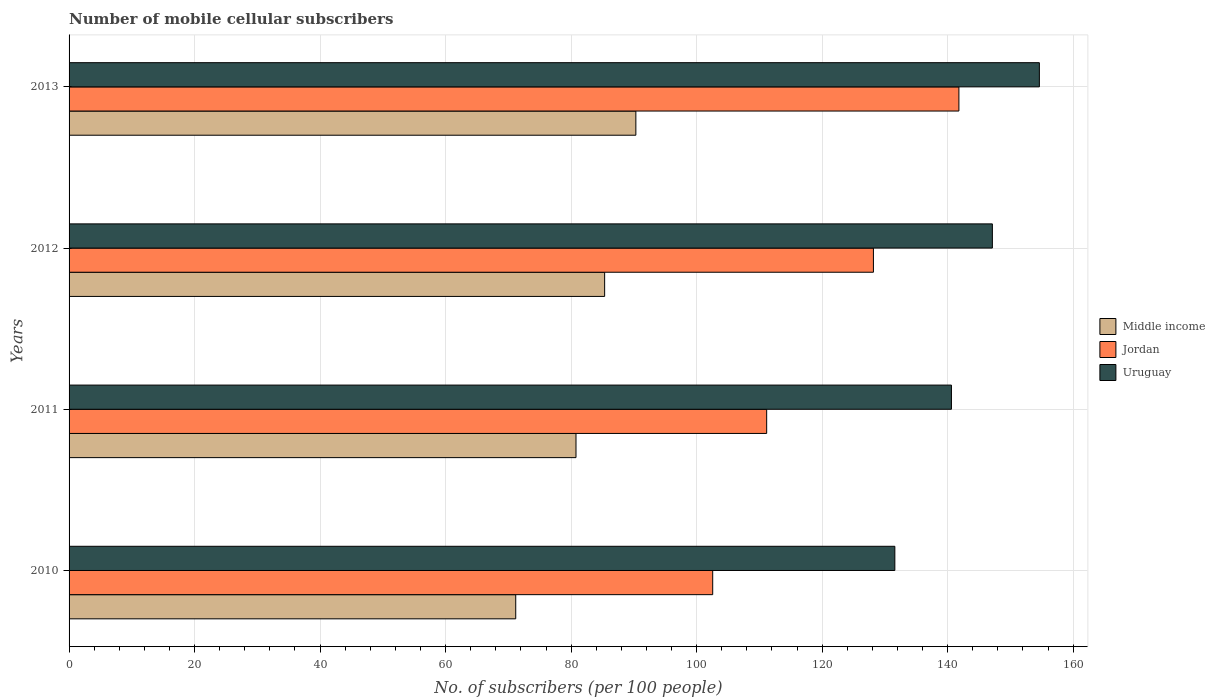How many different coloured bars are there?
Your answer should be very brief. 3. How many groups of bars are there?
Make the answer very short. 4. Are the number of bars per tick equal to the number of legend labels?
Your answer should be very brief. Yes. Are the number of bars on each tick of the Y-axis equal?
Your answer should be very brief. Yes. How many bars are there on the 1st tick from the top?
Provide a succinct answer. 3. What is the number of mobile cellular subscribers in Uruguay in 2013?
Give a very brief answer. 154.62. Across all years, what is the maximum number of mobile cellular subscribers in Middle income?
Keep it short and to the point. 90.32. Across all years, what is the minimum number of mobile cellular subscribers in Uruguay?
Keep it short and to the point. 131.59. What is the total number of mobile cellular subscribers in Uruguay in the graph?
Your answer should be compact. 573.95. What is the difference between the number of mobile cellular subscribers in Jordan in 2010 and that in 2012?
Make the answer very short. -25.61. What is the difference between the number of mobile cellular subscribers in Jordan in 2013 and the number of mobile cellular subscribers in Uruguay in 2012?
Provide a succinct answer. -5.33. What is the average number of mobile cellular subscribers in Middle income per year?
Your answer should be compact. 81.91. In the year 2010, what is the difference between the number of mobile cellular subscribers in Middle income and number of mobile cellular subscribers in Jordan?
Give a very brief answer. -31.39. What is the ratio of the number of mobile cellular subscribers in Middle income in 2011 to that in 2013?
Offer a very short reply. 0.89. Is the difference between the number of mobile cellular subscribers in Middle income in 2011 and 2013 greater than the difference between the number of mobile cellular subscribers in Jordan in 2011 and 2013?
Provide a succinct answer. Yes. What is the difference between the highest and the second highest number of mobile cellular subscribers in Jordan?
Provide a succinct answer. 13.62. What is the difference between the highest and the lowest number of mobile cellular subscribers in Uruguay?
Provide a short and direct response. 23.03. In how many years, is the number of mobile cellular subscribers in Uruguay greater than the average number of mobile cellular subscribers in Uruguay taken over all years?
Provide a short and direct response. 2. Is the sum of the number of mobile cellular subscribers in Middle income in 2011 and 2013 greater than the maximum number of mobile cellular subscribers in Uruguay across all years?
Make the answer very short. Yes. What does the 1st bar from the bottom in 2012 represents?
Offer a very short reply. Middle income. How many bars are there?
Your answer should be compact. 12. Are all the bars in the graph horizontal?
Make the answer very short. Yes. How many years are there in the graph?
Offer a very short reply. 4. What is the difference between two consecutive major ticks on the X-axis?
Give a very brief answer. 20. Does the graph contain any zero values?
Provide a short and direct response. No. What is the title of the graph?
Ensure brevity in your answer.  Number of mobile cellular subscribers. Does "Vietnam" appear as one of the legend labels in the graph?
Offer a very short reply. No. What is the label or title of the X-axis?
Make the answer very short. No. of subscribers (per 100 people). What is the No. of subscribers (per 100 people) of Middle income in 2010?
Ensure brevity in your answer.  71.18. What is the No. of subscribers (per 100 people) in Jordan in 2010?
Your response must be concise. 102.56. What is the No. of subscribers (per 100 people) in Uruguay in 2010?
Give a very brief answer. 131.59. What is the No. of subscribers (per 100 people) of Middle income in 2011?
Provide a succinct answer. 80.78. What is the No. of subscribers (per 100 people) in Jordan in 2011?
Your answer should be compact. 111.16. What is the No. of subscribers (per 100 people) in Uruguay in 2011?
Offer a terse response. 140.61. What is the No. of subscribers (per 100 people) of Middle income in 2012?
Keep it short and to the point. 85.35. What is the No. of subscribers (per 100 people) in Jordan in 2012?
Provide a succinct answer. 128.17. What is the No. of subscribers (per 100 people) in Uruguay in 2012?
Offer a very short reply. 147.13. What is the No. of subscribers (per 100 people) of Middle income in 2013?
Offer a terse response. 90.32. What is the No. of subscribers (per 100 people) of Jordan in 2013?
Keep it short and to the point. 141.8. What is the No. of subscribers (per 100 people) of Uruguay in 2013?
Ensure brevity in your answer.  154.62. Across all years, what is the maximum No. of subscribers (per 100 people) in Middle income?
Your answer should be very brief. 90.32. Across all years, what is the maximum No. of subscribers (per 100 people) of Jordan?
Offer a terse response. 141.8. Across all years, what is the maximum No. of subscribers (per 100 people) of Uruguay?
Provide a succinct answer. 154.62. Across all years, what is the minimum No. of subscribers (per 100 people) of Middle income?
Your response must be concise. 71.18. Across all years, what is the minimum No. of subscribers (per 100 people) of Jordan?
Offer a very short reply. 102.56. Across all years, what is the minimum No. of subscribers (per 100 people) in Uruguay?
Offer a very short reply. 131.59. What is the total No. of subscribers (per 100 people) of Middle income in the graph?
Make the answer very short. 327.62. What is the total No. of subscribers (per 100 people) of Jordan in the graph?
Provide a short and direct response. 483.7. What is the total No. of subscribers (per 100 people) of Uruguay in the graph?
Offer a very short reply. 573.95. What is the difference between the No. of subscribers (per 100 people) in Middle income in 2010 and that in 2011?
Give a very brief answer. -9.6. What is the difference between the No. of subscribers (per 100 people) of Jordan in 2010 and that in 2011?
Offer a terse response. -8.6. What is the difference between the No. of subscribers (per 100 people) in Uruguay in 2010 and that in 2011?
Ensure brevity in your answer.  -9.02. What is the difference between the No. of subscribers (per 100 people) in Middle income in 2010 and that in 2012?
Provide a succinct answer. -14.17. What is the difference between the No. of subscribers (per 100 people) in Jordan in 2010 and that in 2012?
Make the answer very short. -25.61. What is the difference between the No. of subscribers (per 100 people) of Uruguay in 2010 and that in 2012?
Provide a succinct answer. -15.54. What is the difference between the No. of subscribers (per 100 people) in Middle income in 2010 and that in 2013?
Your answer should be compact. -19.14. What is the difference between the No. of subscribers (per 100 people) in Jordan in 2010 and that in 2013?
Ensure brevity in your answer.  -39.23. What is the difference between the No. of subscribers (per 100 people) of Uruguay in 2010 and that in 2013?
Offer a very short reply. -23.03. What is the difference between the No. of subscribers (per 100 people) in Middle income in 2011 and that in 2012?
Make the answer very short. -4.57. What is the difference between the No. of subscribers (per 100 people) in Jordan in 2011 and that in 2012?
Offer a very short reply. -17.01. What is the difference between the No. of subscribers (per 100 people) of Uruguay in 2011 and that in 2012?
Offer a very short reply. -6.52. What is the difference between the No. of subscribers (per 100 people) in Middle income in 2011 and that in 2013?
Keep it short and to the point. -9.54. What is the difference between the No. of subscribers (per 100 people) in Jordan in 2011 and that in 2013?
Your answer should be very brief. -30.63. What is the difference between the No. of subscribers (per 100 people) of Uruguay in 2011 and that in 2013?
Provide a succinct answer. -14.01. What is the difference between the No. of subscribers (per 100 people) in Middle income in 2012 and that in 2013?
Give a very brief answer. -4.97. What is the difference between the No. of subscribers (per 100 people) in Jordan in 2012 and that in 2013?
Keep it short and to the point. -13.62. What is the difference between the No. of subscribers (per 100 people) of Uruguay in 2012 and that in 2013?
Offer a terse response. -7.49. What is the difference between the No. of subscribers (per 100 people) of Middle income in 2010 and the No. of subscribers (per 100 people) of Jordan in 2011?
Ensure brevity in your answer.  -39.99. What is the difference between the No. of subscribers (per 100 people) of Middle income in 2010 and the No. of subscribers (per 100 people) of Uruguay in 2011?
Your answer should be very brief. -69.43. What is the difference between the No. of subscribers (per 100 people) of Jordan in 2010 and the No. of subscribers (per 100 people) of Uruguay in 2011?
Your answer should be very brief. -38.04. What is the difference between the No. of subscribers (per 100 people) of Middle income in 2010 and the No. of subscribers (per 100 people) of Jordan in 2012?
Make the answer very short. -57. What is the difference between the No. of subscribers (per 100 people) in Middle income in 2010 and the No. of subscribers (per 100 people) in Uruguay in 2012?
Give a very brief answer. -75.95. What is the difference between the No. of subscribers (per 100 people) of Jordan in 2010 and the No. of subscribers (per 100 people) of Uruguay in 2012?
Offer a terse response. -44.57. What is the difference between the No. of subscribers (per 100 people) in Middle income in 2010 and the No. of subscribers (per 100 people) in Jordan in 2013?
Give a very brief answer. -70.62. What is the difference between the No. of subscribers (per 100 people) of Middle income in 2010 and the No. of subscribers (per 100 people) of Uruguay in 2013?
Keep it short and to the point. -83.44. What is the difference between the No. of subscribers (per 100 people) of Jordan in 2010 and the No. of subscribers (per 100 people) of Uruguay in 2013?
Offer a terse response. -52.06. What is the difference between the No. of subscribers (per 100 people) in Middle income in 2011 and the No. of subscribers (per 100 people) in Jordan in 2012?
Give a very brief answer. -47.39. What is the difference between the No. of subscribers (per 100 people) in Middle income in 2011 and the No. of subscribers (per 100 people) in Uruguay in 2012?
Your answer should be very brief. -66.35. What is the difference between the No. of subscribers (per 100 people) of Jordan in 2011 and the No. of subscribers (per 100 people) of Uruguay in 2012?
Ensure brevity in your answer.  -35.97. What is the difference between the No. of subscribers (per 100 people) in Middle income in 2011 and the No. of subscribers (per 100 people) in Jordan in 2013?
Make the answer very short. -61.02. What is the difference between the No. of subscribers (per 100 people) in Middle income in 2011 and the No. of subscribers (per 100 people) in Uruguay in 2013?
Make the answer very short. -73.84. What is the difference between the No. of subscribers (per 100 people) in Jordan in 2011 and the No. of subscribers (per 100 people) in Uruguay in 2013?
Ensure brevity in your answer.  -43.46. What is the difference between the No. of subscribers (per 100 people) of Middle income in 2012 and the No. of subscribers (per 100 people) of Jordan in 2013?
Make the answer very short. -56.45. What is the difference between the No. of subscribers (per 100 people) of Middle income in 2012 and the No. of subscribers (per 100 people) of Uruguay in 2013?
Give a very brief answer. -69.27. What is the difference between the No. of subscribers (per 100 people) of Jordan in 2012 and the No. of subscribers (per 100 people) of Uruguay in 2013?
Make the answer very short. -26.44. What is the average No. of subscribers (per 100 people) of Middle income per year?
Ensure brevity in your answer.  81.91. What is the average No. of subscribers (per 100 people) in Jordan per year?
Offer a very short reply. 120.92. What is the average No. of subscribers (per 100 people) in Uruguay per year?
Keep it short and to the point. 143.49. In the year 2010, what is the difference between the No. of subscribers (per 100 people) of Middle income and No. of subscribers (per 100 people) of Jordan?
Provide a succinct answer. -31.39. In the year 2010, what is the difference between the No. of subscribers (per 100 people) of Middle income and No. of subscribers (per 100 people) of Uruguay?
Give a very brief answer. -60.41. In the year 2010, what is the difference between the No. of subscribers (per 100 people) in Jordan and No. of subscribers (per 100 people) in Uruguay?
Make the answer very short. -29.03. In the year 2011, what is the difference between the No. of subscribers (per 100 people) of Middle income and No. of subscribers (per 100 people) of Jordan?
Your answer should be very brief. -30.38. In the year 2011, what is the difference between the No. of subscribers (per 100 people) of Middle income and No. of subscribers (per 100 people) of Uruguay?
Your answer should be compact. -59.83. In the year 2011, what is the difference between the No. of subscribers (per 100 people) in Jordan and No. of subscribers (per 100 people) in Uruguay?
Offer a very short reply. -29.44. In the year 2012, what is the difference between the No. of subscribers (per 100 people) in Middle income and No. of subscribers (per 100 people) in Jordan?
Your response must be concise. -42.83. In the year 2012, what is the difference between the No. of subscribers (per 100 people) in Middle income and No. of subscribers (per 100 people) in Uruguay?
Offer a very short reply. -61.79. In the year 2012, what is the difference between the No. of subscribers (per 100 people) in Jordan and No. of subscribers (per 100 people) in Uruguay?
Offer a very short reply. -18.96. In the year 2013, what is the difference between the No. of subscribers (per 100 people) of Middle income and No. of subscribers (per 100 people) of Jordan?
Give a very brief answer. -51.48. In the year 2013, what is the difference between the No. of subscribers (per 100 people) of Middle income and No. of subscribers (per 100 people) of Uruguay?
Your response must be concise. -64.3. In the year 2013, what is the difference between the No. of subscribers (per 100 people) in Jordan and No. of subscribers (per 100 people) in Uruguay?
Offer a terse response. -12.82. What is the ratio of the No. of subscribers (per 100 people) of Middle income in 2010 to that in 2011?
Offer a very short reply. 0.88. What is the ratio of the No. of subscribers (per 100 people) in Jordan in 2010 to that in 2011?
Your answer should be compact. 0.92. What is the ratio of the No. of subscribers (per 100 people) in Uruguay in 2010 to that in 2011?
Provide a succinct answer. 0.94. What is the ratio of the No. of subscribers (per 100 people) in Middle income in 2010 to that in 2012?
Ensure brevity in your answer.  0.83. What is the ratio of the No. of subscribers (per 100 people) of Jordan in 2010 to that in 2012?
Your answer should be compact. 0.8. What is the ratio of the No. of subscribers (per 100 people) of Uruguay in 2010 to that in 2012?
Your response must be concise. 0.89. What is the ratio of the No. of subscribers (per 100 people) in Middle income in 2010 to that in 2013?
Your answer should be very brief. 0.79. What is the ratio of the No. of subscribers (per 100 people) in Jordan in 2010 to that in 2013?
Give a very brief answer. 0.72. What is the ratio of the No. of subscribers (per 100 people) of Uruguay in 2010 to that in 2013?
Keep it short and to the point. 0.85. What is the ratio of the No. of subscribers (per 100 people) of Middle income in 2011 to that in 2012?
Your response must be concise. 0.95. What is the ratio of the No. of subscribers (per 100 people) of Jordan in 2011 to that in 2012?
Your response must be concise. 0.87. What is the ratio of the No. of subscribers (per 100 people) in Uruguay in 2011 to that in 2012?
Give a very brief answer. 0.96. What is the ratio of the No. of subscribers (per 100 people) in Middle income in 2011 to that in 2013?
Your response must be concise. 0.89. What is the ratio of the No. of subscribers (per 100 people) of Jordan in 2011 to that in 2013?
Keep it short and to the point. 0.78. What is the ratio of the No. of subscribers (per 100 people) of Uruguay in 2011 to that in 2013?
Offer a very short reply. 0.91. What is the ratio of the No. of subscribers (per 100 people) of Middle income in 2012 to that in 2013?
Offer a very short reply. 0.94. What is the ratio of the No. of subscribers (per 100 people) in Jordan in 2012 to that in 2013?
Your answer should be compact. 0.9. What is the ratio of the No. of subscribers (per 100 people) in Uruguay in 2012 to that in 2013?
Your answer should be compact. 0.95. What is the difference between the highest and the second highest No. of subscribers (per 100 people) in Middle income?
Give a very brief answer. 4.97. What is the difference between the highest and the second highest No. of subscribers (per 100 people) in Jordan?
Your answer should be compact. 13.62. What is the difference between the highest and the second highest No. of subscribers (per 100 people) of Uruguay?
Give a very brief answer. 7.49. What is the difference between the highest and the lowest No. of subscribers (per 100 people) in Middle income?
Give a very brief answer. 19.14. What is the difference between the highest and the lowest No. of subscribers (per 100 people) in Jordan?
Your response must be concise. 39.23. What is the difference between the highest and the lowest No. of subscribers (per 100 people) in Uruguay?
Offer a very short reply. 23.03. 